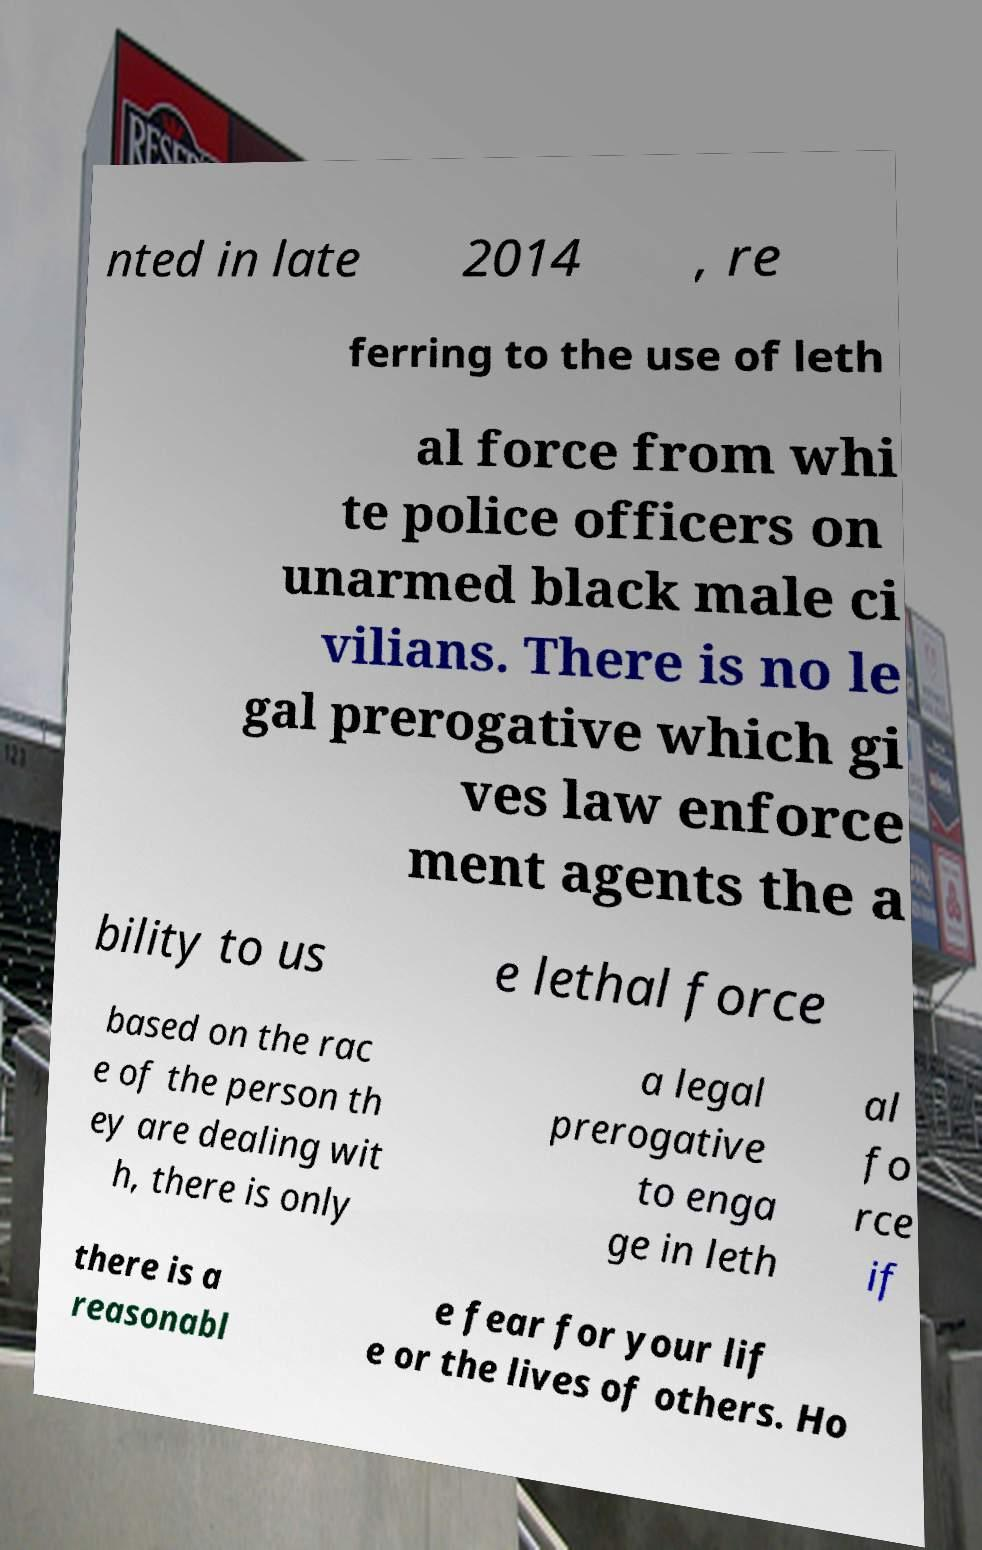What messages or text are displayed in this image? I need them in a readable, typed format. nted in late 2014 , re ferring to the use of leth al force from whi te police officers on unarmed black male ci vilians. There is no le gal prerogative which gi ves law enforce ment agents the a bility to us e lethal force based on the rac e of the person th ey are dealing wit h, there is only a legal prerogative to enga ge in leth al fo rce if there is a reasonabl e fear for your lif e or the lives of others. Ho 